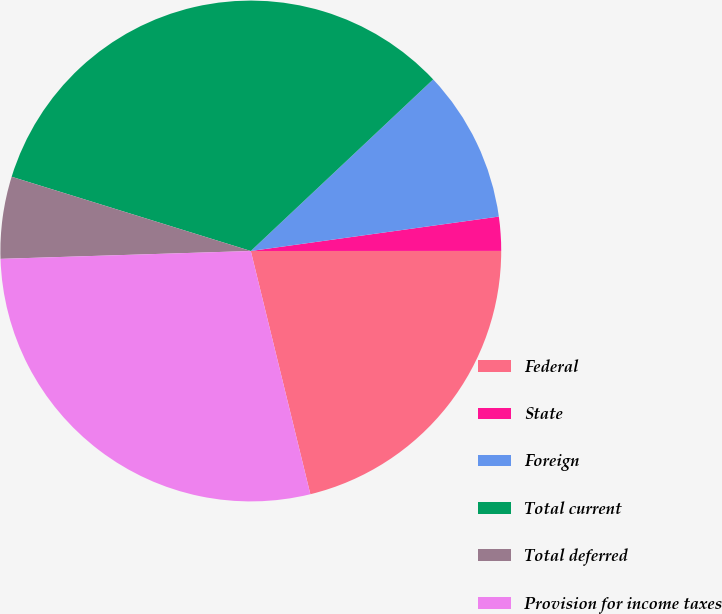Convert chart. <chart><loc_0><loc_0><loc_500><loc_500><pie_chart><fcel>Federal<fcel>State<fcel>Foreign<fcel>Total current<fcel>Total deferred<fcel>Provision for income taxes<nl><fcel>21.18%<fcel>2.19%<fcel>9.82%<fcel>33.19%<fcel>5.29%<fcel>28.32%<nl></chart> 